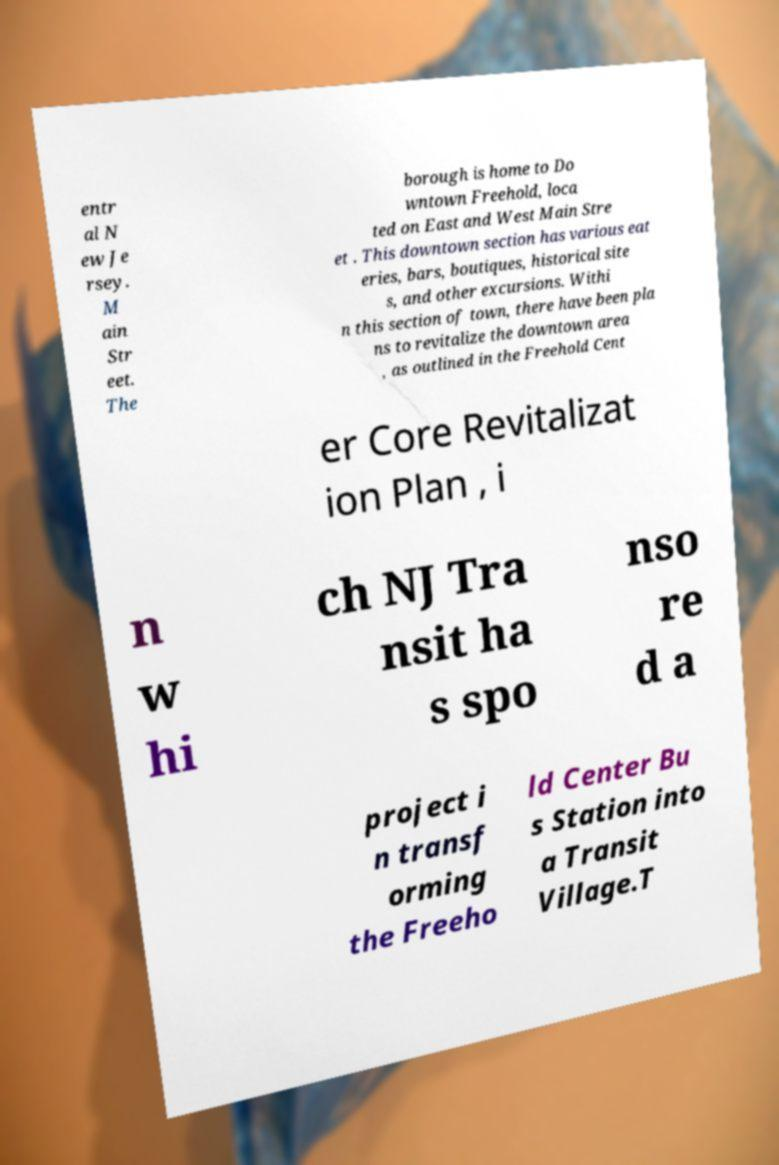Could you assist in decoding the text presented in this image and type it out clearly? entr al N ew Je rsey. M ain Str eet. The borough is home to Do wntown Freehold, loca ted on East and West Main Stre et . This downtown section has various eat eries, bars, boutiques, historical site s, and other excursions. Withi n this section of town, there have been pla ns to revitalize the downtown area , as outlined in the Freehold Cent er Core Revitalizat ion Plan , i n w hi ch NJ Tra nsit ha s spo nso re d a project i n transf orming the Freeho ld Center Bu s Station into a Transit Village.T 